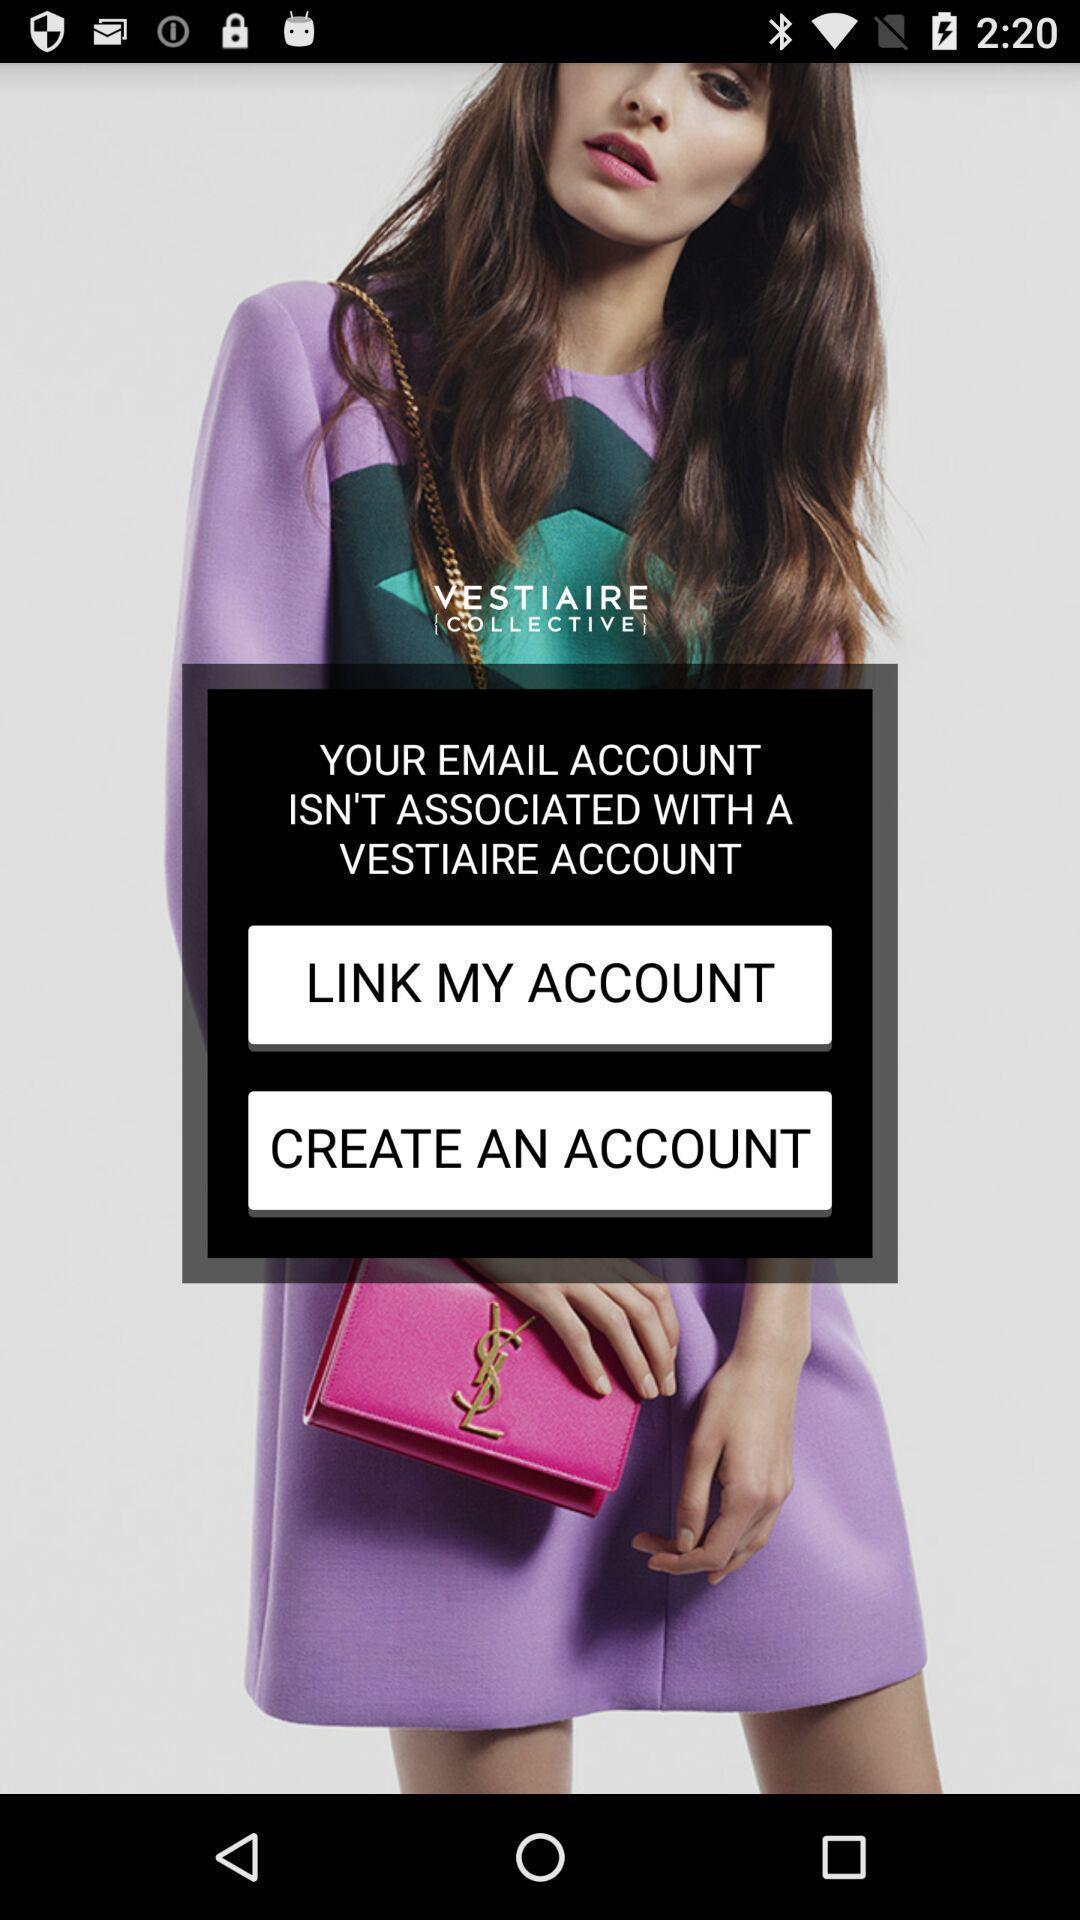Tell me about the visual elements in this screen capture. Welcome page. 